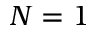Convert formula to latex. <formula><loc_0><loc_0><loc_500><loc_500>N = 1</formula> 